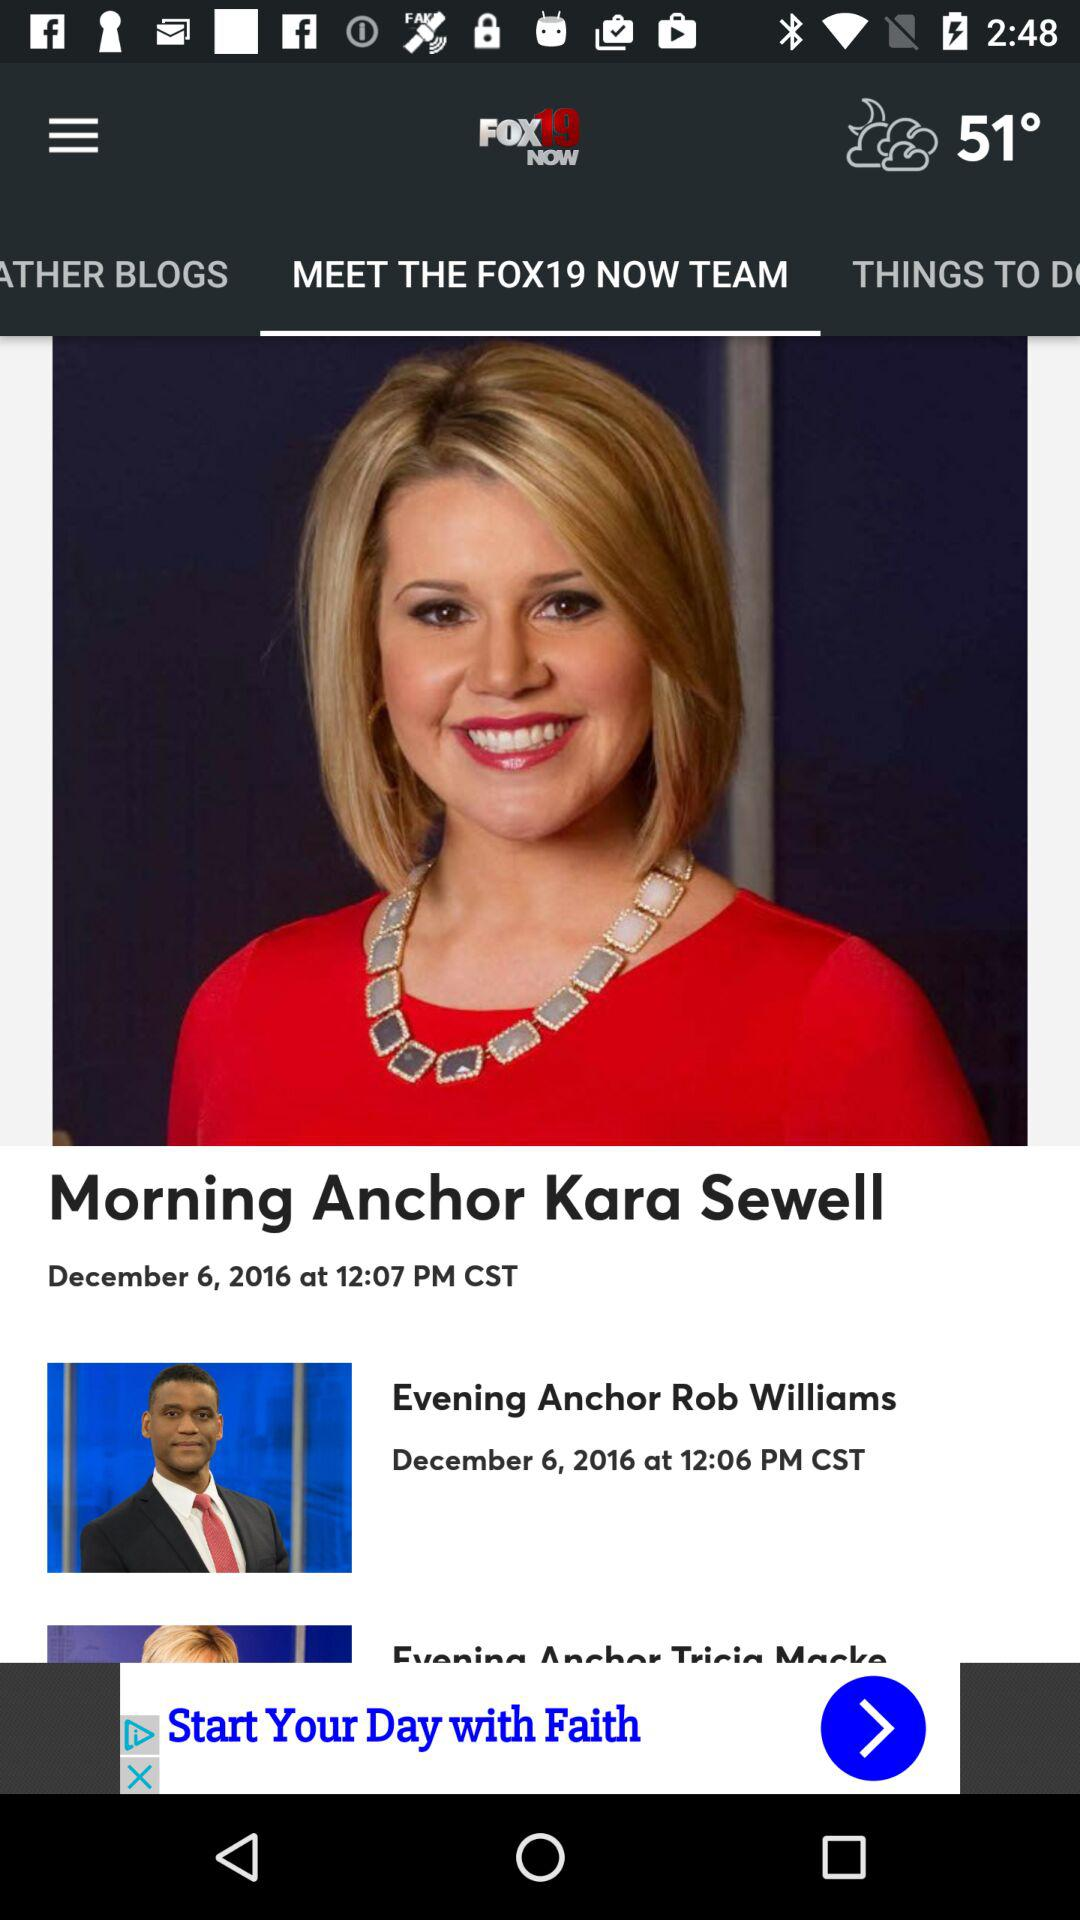How many anchors are there on the show?
Answer the question using a single word or phrase. 3 